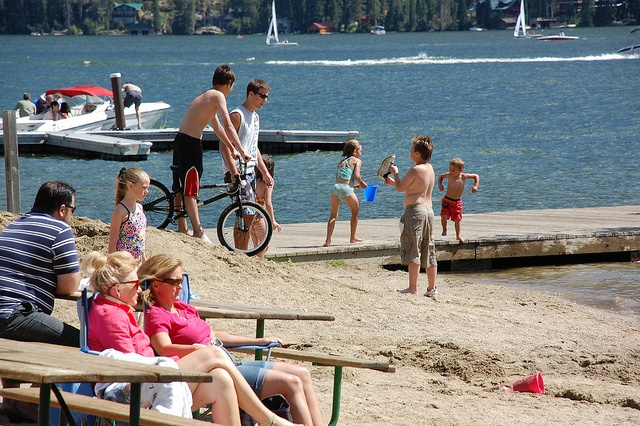Describe the objects in this image and their specific colors. I can see people in black, lightpink, white, salmon, and tan tones, people in black, gray, navy, and darkgray tones, people in black, lightpink, tan, lightgray, and violet tones, bench in black, tan, and maroon tones, and dining table in black, tan, and maroon tones in this image. 